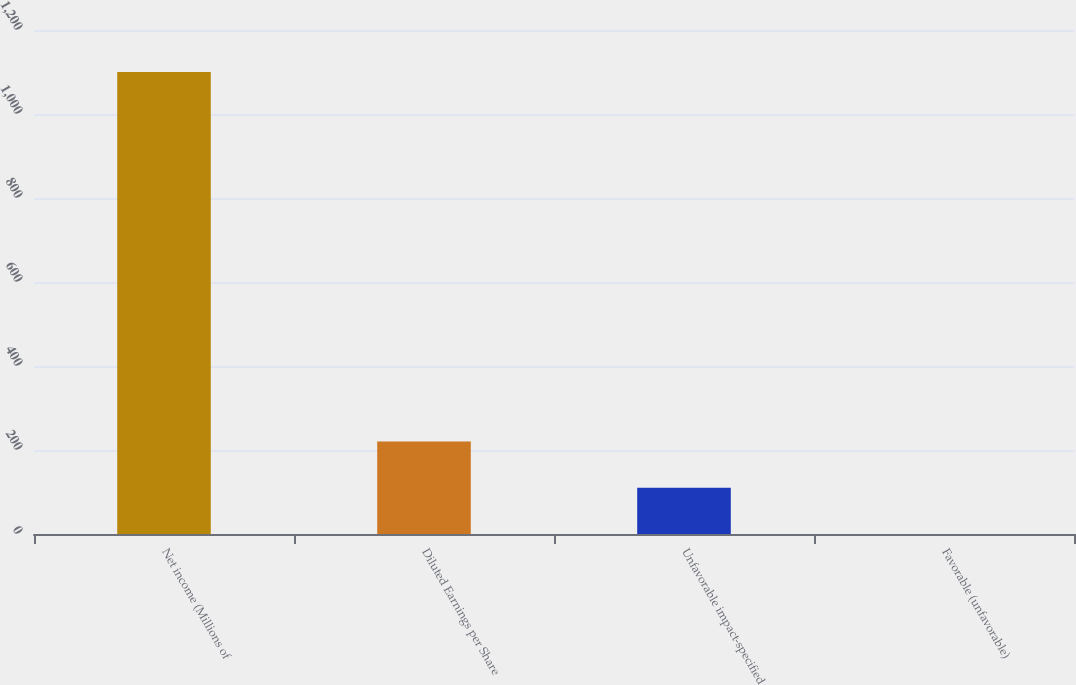Convert chart to OTSL. <chart><loc_0><loc_0><loc_500><loc_500><bar_chart><fcel>Net income (Millions of<fcel>Diluted Earnings per Share<fcel>Unfavorable impact-specified<fcel>Favorable (unfavorable)<nl><fcel>1100<fcel>220.19<fcel>110.21<fcel>0.23<nl></chart> 